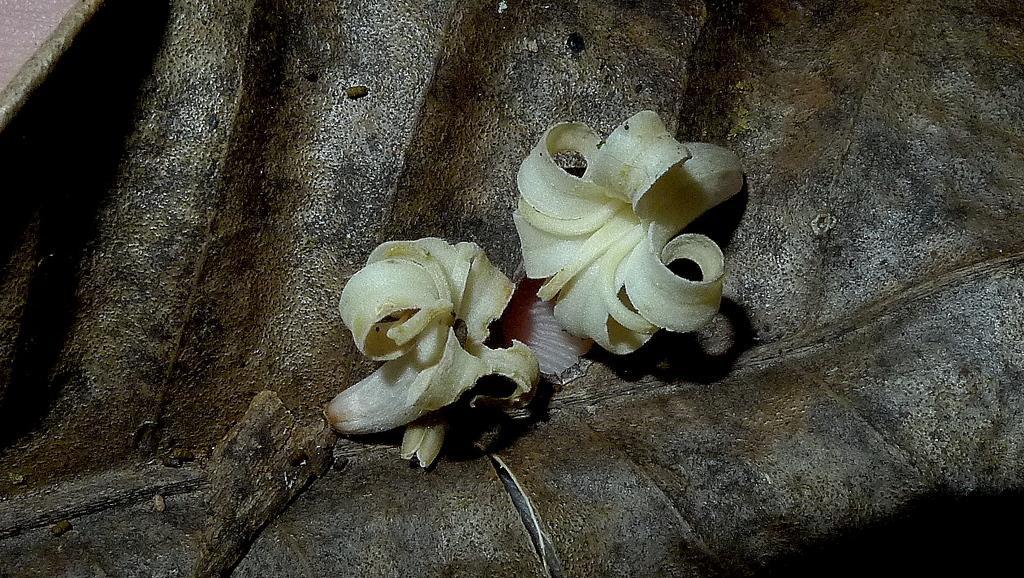How would you summarize this image in a sentence or two? In this image in the center there are flowers, and in the background there is some object. 